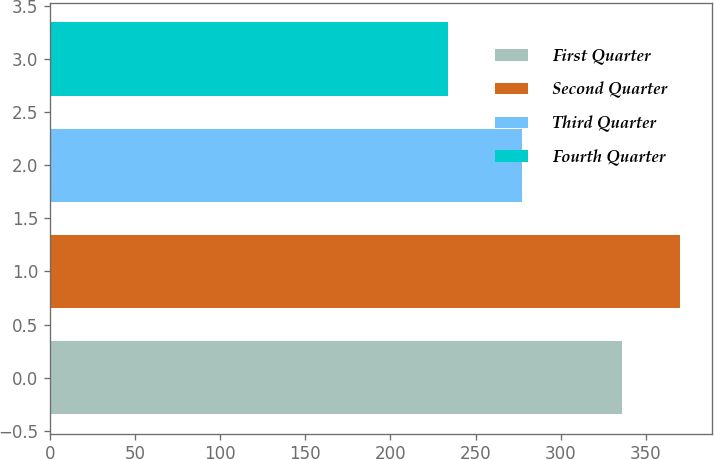<chart> <loc_0><loc_0><loc_500><loc_500><bar_chart><fcel>First Quarter<fcel>Second Quarter<fcel>Third Quarter<fcel>Fourth Quarter<nl><fcel>336.29<fcel>370.19<fcel>277.26<fcel>233.82<nl></chart> 